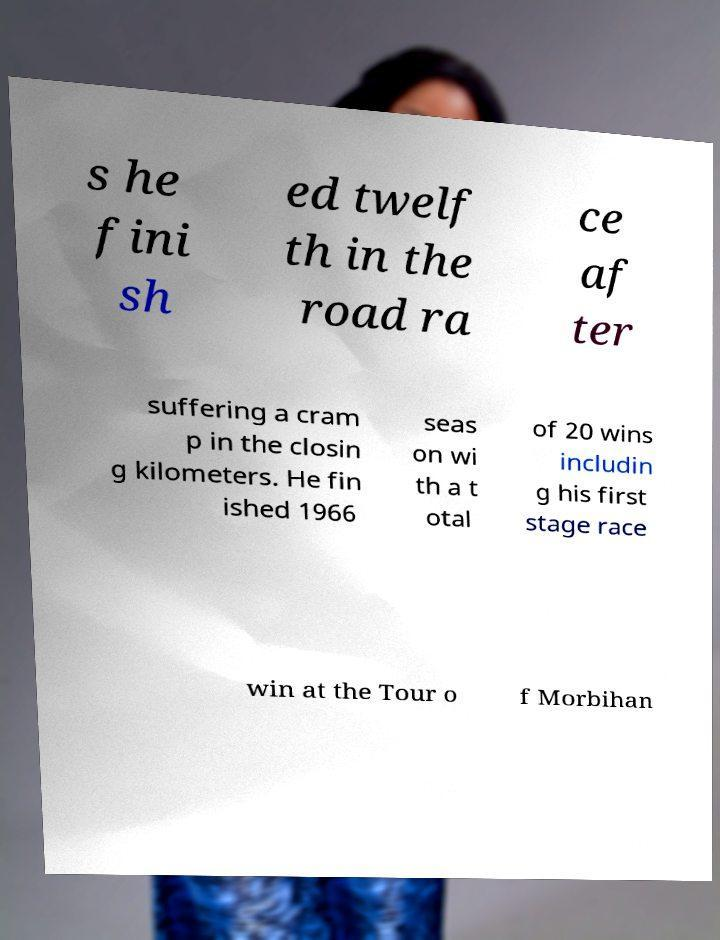I need the written content from this picture converted into text. Can you do that? s he fini sh ed twelf th in the road ra ce af ter suffering a cram p in the closin g kilometers. He fin ished 1966 seas on wi th a t otal of 20 wins includin g his first stage race win at the Tour o f Morbihan 